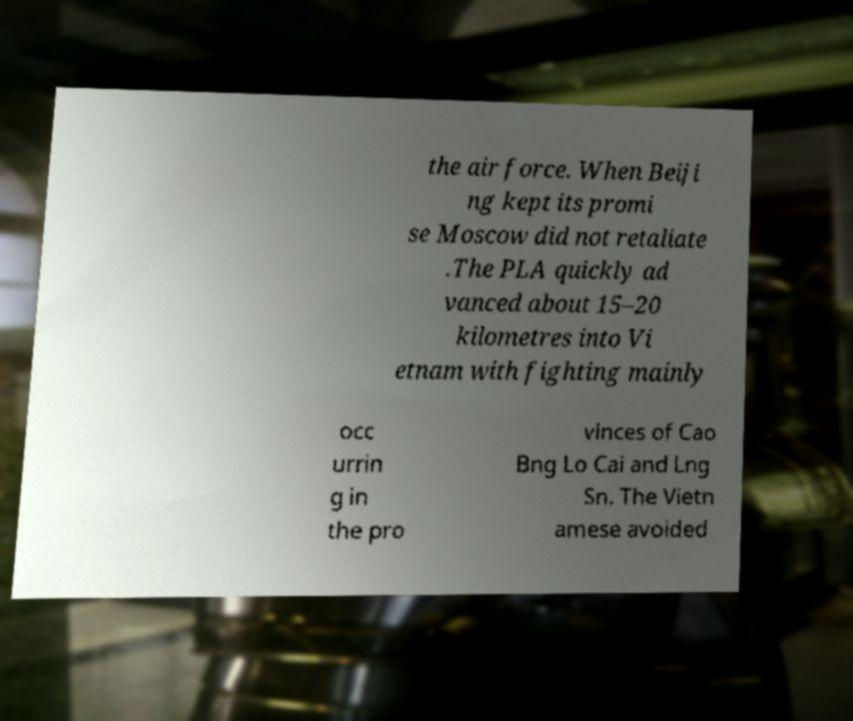For documentation purposes, I need the text within this image transcribed. Could you provide that? the air force. When Beiji ng kept its promi se Moscow did not retaliate .The PLA quickly ad vanced about 15–20 kilometres into Vi etnam with fighting mainly occ urrin g in the pro vinces of Cao Bng Lo Cai and Lng Sn. The Vietn amese avoided 